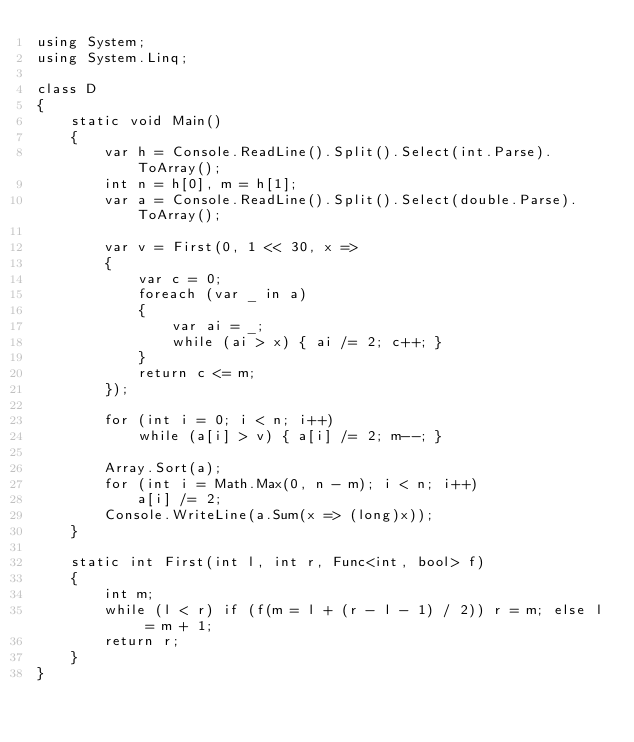Convert code to text. <code><loc_0><loc_0><loc_500><loc_500><_C#_>using System;
using System.Linq;

class D
{
	static void Main()
	{
		var h = Console.ReadLine().Split().Select(int.Parse).ToArray();
		int n = h[0], m = h[1];
		var a = Console.ReadLine().Split().Select(double.Parse).ToArray();

		var v = First(0, 1 << 30, x =>
		{
			var c = 0;
			foreach (var _ in a)
			{
				var ai = _;
				while (ai > x) { ai /= 2; c++; }
			}
			return c <= m;
		});

		for (int i = 0; i < n; i++)
			while (a[i] > v) { a[i] /= 2; m--; }

		Array.Sort(a);
		for (int i = Math.Max(0, n - m); i < n; i++)
			a[i] /= 2;
		Console.WriteLine(a.Sum(x => (long)x));
	}

	static int First(int l, int r, Func<int, bool> f)
	{
		int m;
		while (l < r) if (f(m = l + (r - l - 1) / 2)) r = m; else l = m + 1;
		return r;
	}
}
</code> 